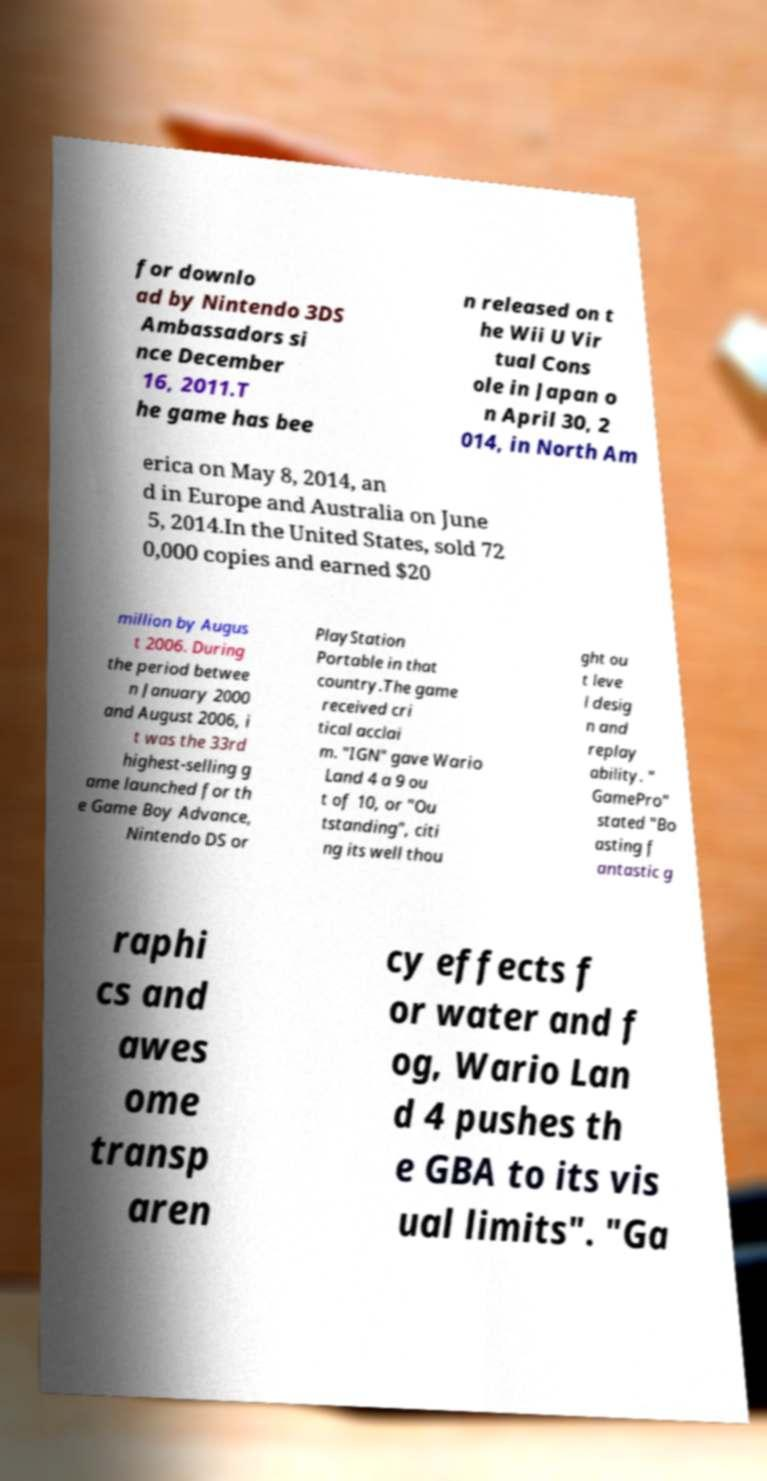Can you read and provide the text displayed in the image?This photo seems to have some interesting text. Can you extract and type it out for me? for downlo ad by Nintendo 3DS Ambassadors si nce December 16, 2011.T he game has bee n released on t he Wii U Vir tual Cons ole in Japan o n April 30, 2 014, in North Am erica on May 8, 2014, an d in Europe and Australia on June 5, 2014.In the United States, sold 72 0,000 copies and earned $20 million by Augus t 2006. During the period betwee n January 2000 and August 2006, i t was the 33rd highest-selling g ame launched for th e Game Boy Advance, Nintendo DS or PlayStation Portable in that country.The game received cri tical acclai m. "IGN" gave Wario Land 4 a 9 ou t of 10, or "Ou tstanding", citi ng its well thou ght ou t leve l desig n and replay ability. " GamePro" stated "Bo asting f antastic g raphi cs and awes ome transp aren cy effects f or water and f og, Wario Lan d 4 pushes th e GBA to its vis ual limits". "Ga 